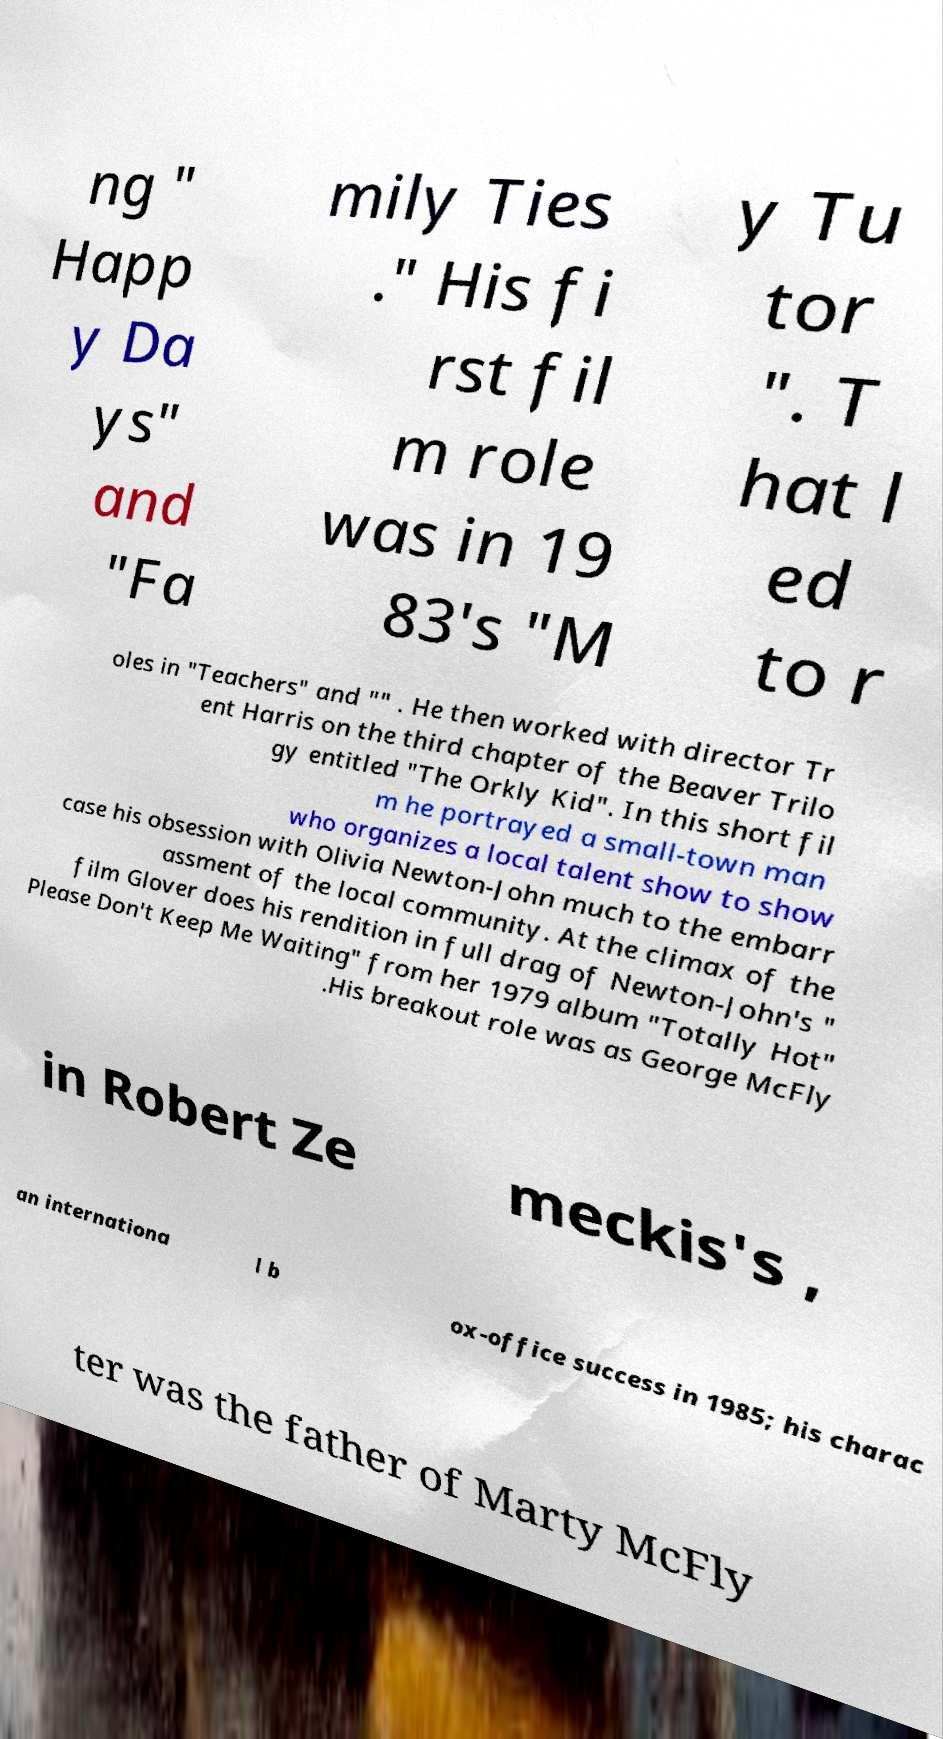Could you assist in decoding the text presented in this image and type it out clearly? ng " Happ y Da ys" and "Fa mily Ties ." His fi rst fil m role was in 19 83's "M y Tu tor ". T hat l ed to r oles in "Teachers" and "" . He then worked with director Tr ent Harris on the third chapter of the Beaver Trilo gy entitled "The Orkly Kid". In this short fil m he portrayed a small-town man who organizes a local talent show to show case his obsession with Olivia Newton-John much to the embarr assment of the local community. At the climax of the film Glover does his rendition in full drag of Newton-John's " Please Don't Keep Me Waiting" from her 1979 album "Totally Hot" .His breakout role was as George McFly in Robert Ze meckis's , an internationa l b ox-office success in 1985; his charac ter was the father of Marty McFly 